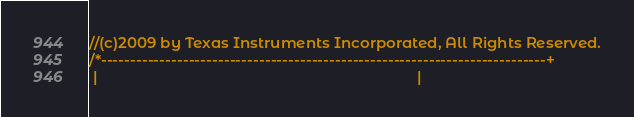<code> <loc_0><loc_0><loc_500><loc_500><_C_>//(c)2009 by Texas Instruments Incorporated, All Rights Reserved.
/*----------------------------------------------------------------------------+
 |                                                                             |</code> 